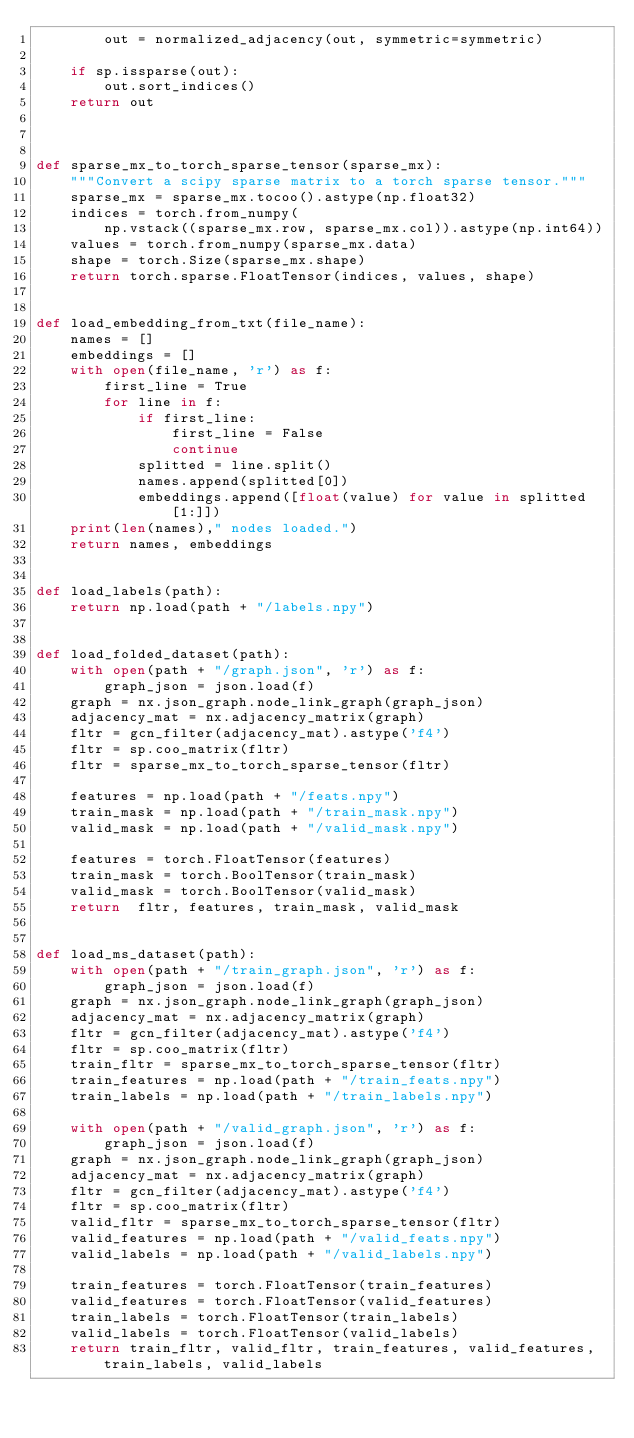<code> <loc_0><loc_0><loc_500><loc_500><_Python_>        out = normalized_adjacency(out, symmetric=symmetric)

    if sp.issparse(out):
        out.sort_indices()
    return out



def sparse_mx_to_torch_sparse_tensor(sparse_mx):
    """Convert a scipy sparse matrix to a torch sparse tensor."""
    sparse_mx = sparse_mx.tocoo().astype(np.float32)
    indices = torch.from_numpy(
        np.vstack((sparse_mx.row, sparse_mx.col)).astype(np.int64))
    values = torch.from_numpy(sparse_mx.data)
    shape = torch.Size(sparse_mx.shape)
    return torch.sparse.FloatTensor(indices, values, shape)


def load_embedding_from_txt(file_name):
    names = []
    embeddings = []
    with open(file_name, 'r') as f:
        first_line = True
        for line in f:
            if first_line:
                first_line = False
                continue
            splitted = line.split()
            names.append(splitted[0])
            embeddings.append([float(value) for value in splitted[1:]])
    print(len(names)," nodes loaded.")
    return names, embeddings


def load_labels(path):
    return np.load(path + "/labels.npy")


def load_folded_dataset(path):
    with open(path + "/graph.json", 'r') as f:
        graph_json = json.load(f)
    graph = nx.json_graph.node_link_graph(graph_json)
    adjacency_mat = nx.adjacency_matrix(graph)
    fltr = gcn_filter(adjacency_mat).astype('f4')
    fltr = sp.coo_matrix(fltr)
    fltr = sparse_mx_to_torch_sparse_tensor(fltr)

    features = np.load(path + "/feats.npy")
    train_mask = np.load(path + "/train_mask.npy")
    valid_mask = np.load(path + "/valid_mask.npy")

    features = torch.FloatTensor(features)
    train_mask = torch.BoolTensor(train_mask)
    valid_mask = torch.BoolTensor(valid_mask)
    return  fltr, features, train_mask, valid_mask


def load_ms_dataset(path):
    with open(path + "/train_graph.json", 'r') as f:
        graph_json = json.load(f)
    graph = nx.json_graph.node_link_graph(graph_json)
    adjacency_mat = nx.adjacency_matrix(graph)
    fltr = gcn_filter(adjacency_mat).astype('f4')
    fltr = sp.coo_matrix(fltr)
    train_fltr = sparse_mx_to_torch_sparse_tensor(fltr)
    train_features = np.load(path + "/train_feats.npy")
    train_labels = np.load(path + "/train_labels.npy")

    with open(path + "/valid_graph.json", 'r') as f:
        graph_json = json.load(f)
    graph = nx.json_graph.node_link_graph(graph_json)
    adjacency_mat = nx.adjacency_matrix(graph)
    fltr = gcn_filter(adjacency_mat).astype('f4')
    fltr = sp.coo_matrix(fltr)
    valid_fltr = sparse_mx_to_torch_sparse_tensor(fltr)
    valid_features = np.load(path + "/valid_feats.npy")
    valid_labels = np.load(path + "/valid_labels.npy")

    train_features = torch.FloatTensor(train_features)
    valid_features = torch.FloatTensor(valid_features)
    train_labels = torch.FloatTensor(train_labels)
    valid_labels = torch.FloatTensor(valid_labels)
    return train_fltr, valid_fltr, train_features, valid_features, train_labels, valid_labels

</code> 